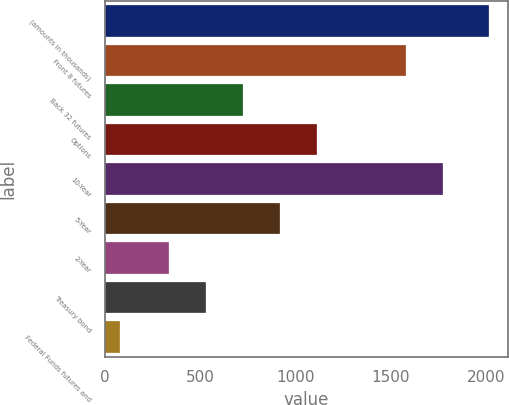Convert chart. <chart><loc_0><loc_0><loc_500><loc_500><bar_chart><fcel>(amounts in thousands)<fcel>Front 8 futures<fcel>Back 32 futures<fcel>Options<fcel>10-Year<fcel>5-Year<fcel>2-Year<fcel>Treasury bond<fcel>Federal Funds futures and<nl><fcel>2015<fcel>1580<fcel>724.8<fcel>1111.6<fcel>1773.4<fcel>918.2<fcel>338<fcel>531.4<fcel>81<nl></chart> 